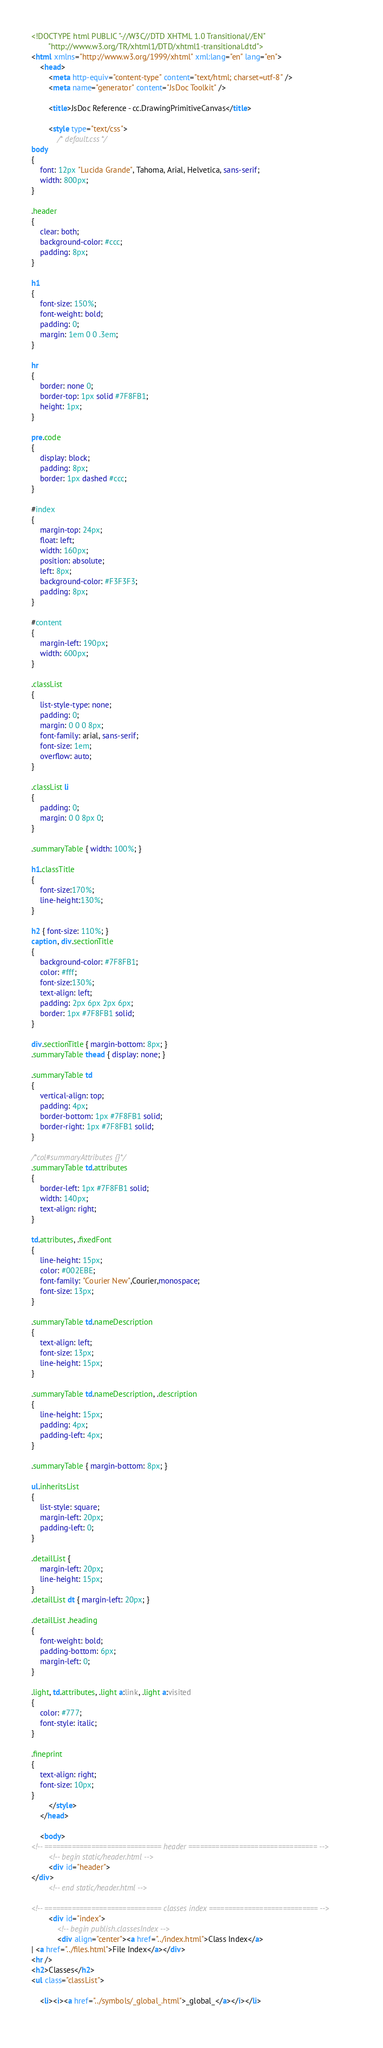<code> <loc_0><loc_0><loc_500><loc_500><_HTML_><!DOCTYPE html PUBLIC "-//W3C//DTD XHTML 1.0 Transitional//EN"
        "http://www.w3.org/TR/xhtml1/DTD/xhtml1-transitional.dtd">
<html xmlns="http://www.w3.org/1999/xhtml" xml:lang="en" lang="en">
	<head>
		<meta http-equiv="content-type" content="text/html; charset=utf-8" />
		<meta name="generator" content="JsDoc Toolkit" />
		
		<title>JsDoc Reference - cc.DrawingPrimitiveCanvas</title>

		<style type="text/css">
			/* default.css */
body
{
	font: 12px "Lucida Grande", Tahoma, Arial, Helvetica, sans-serif;
	width: 800px;
}

.header
{
	clear: both;
	background-color: #ccc;
	padding: 8px;
}

h1
{
	font-size: 150%;
	font-weight: bold;
	padding: 0;
	margin: 1em 0 0 .3em;
}

hr
{
	border: none 0;
	border-top: 1px solid #7F8FB1;
	height: 1px;
}

pre.code
{
	display: block;
	padding: 8px;
	border: 1px dashed #ccc;
}

#index
{
	margin-top: 24px;
	float: left;
	width: 160px;
	position: absolute;
	left: 8px;
	background-color: #F3F3F3;
	padding: 8px;
}

#content
{
	margin-left: 190px;
	width: 600px;
}

.classList
{
	list-style-type: none;
	padding: 0;
	margin: 0 0 0 8px;
	font-family: arial, sans-serif;
	font-size: 1em;
	overflow: auto;
}

.classList li
{
	padding: 0;
	margin: 0 0 8px 0;
}

.summaryTable { width: 100%; }

h1.classTitle
{
	font-size:170%;
	line-height:130%;
}

h2 { font-size: 110%; }
caption, div.sectionTitle
{
	background-color: #7F8FB1;
	color: #fff;
	font-size:130%;
	text-align: left;
	padding: 2px 6px 2px 6px;
	border: 1px #7F8FB1 solid;
}

div.sectionTitle { margin-bottom: 8px; }
.summaryTable thead { display: none; }

.summaryTable td
{
	vertical-align: top;
	padding: 4px;
	border-bottom: 1px #7F8FB1 solid;
	border-right: 1px #7F8FB1 solid;
}

/*col#summaryAttributes {}*/
.summaryTable td.attributes
{
	border-left: 1px #7F8FB1 solid;
	width: 140px;
	text-align: right;
}

td.attributes, .fixedFont
{
	line-height: 15px;
	color: #002EBE;
	font-family: "Courier New",Courier,monospace;
	font-size: 13px;
}

.summaryTable td.nameDescription
{
	text-align: left;
	font-size: 13px;
	line-height: 15px;
}

.summaryTable td.nameDescription, .description
{
	line-height: 15px;
	padding: 4px;
	padding-left: 4px;
}

.summaryTable { margin-bottom: 8px; }

ul.inheritsList
{
	list-style: square;
	margin-left: 20px;
	padding-left: 0;
}

.detailList {
	margin-left: 20px; 
	line-height: 15px;
}
.detailList dt { margin-left: 20px; }

.detailList .heading
{
	font-weight: bold;
	padding-bottom: 6px;
	margin-left: 0;
}

.light, td.attributes, .light a:link, .light a:visited
{
	color: #777;
	font-style: italic;
}

.fineprint
{
	text-align: right;
	font-size: 10px;
}
		</style>
	</head>

	<body>
<!-- ============================== header ================================= -->	
		<!-- begin static/header.html -->
		<div id="header">
</div>
		<!-- end static/header.html -->

<!-- ============================== classes index ============================ -->
		<div id="index">
			<!-- begin publish.classesIndex -->
			<div align="center"><a href="../index.html">Class Index</a>
| <a href="../files.html">File Index</a></div>
<hr />
<h2>Classes</h2>
<ul class="classList">
	
	<li><i><a href="../symbols/_global_.html">_global_</a></i></li>
	</code> 